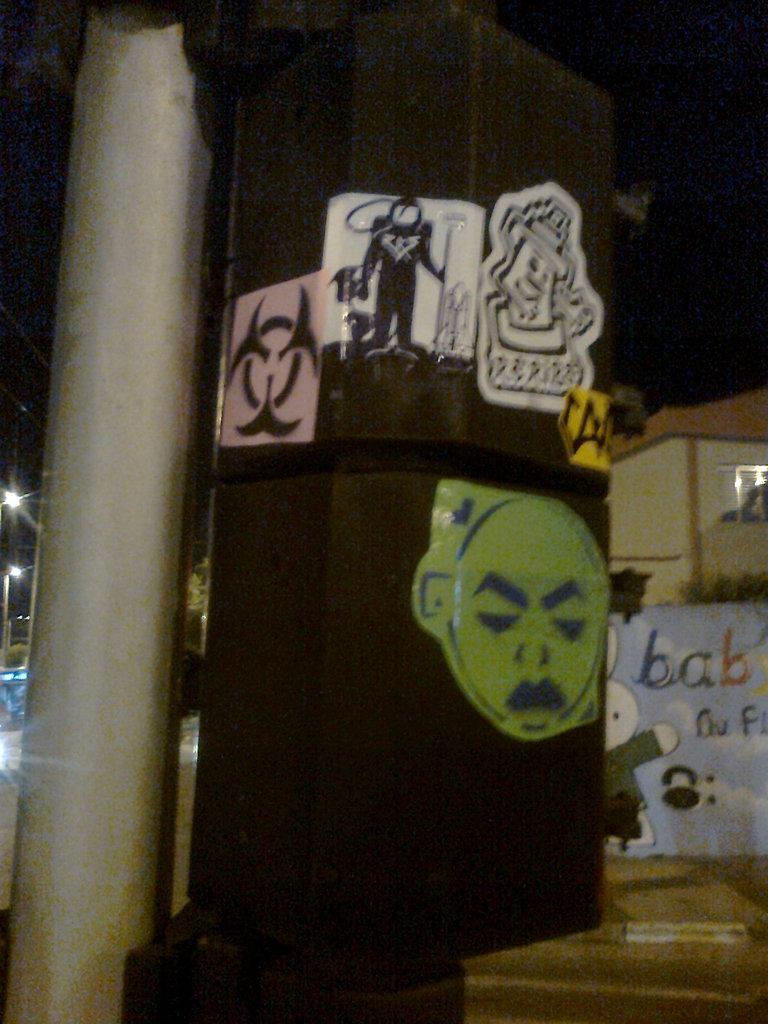Could you give a brief overview of what you see in this image? In this image, we can see a board with some pictures on it and there is a pole. In the background, there are buildings, trees, lights and we can some paintings on the wall. At the bottom, there is road. 